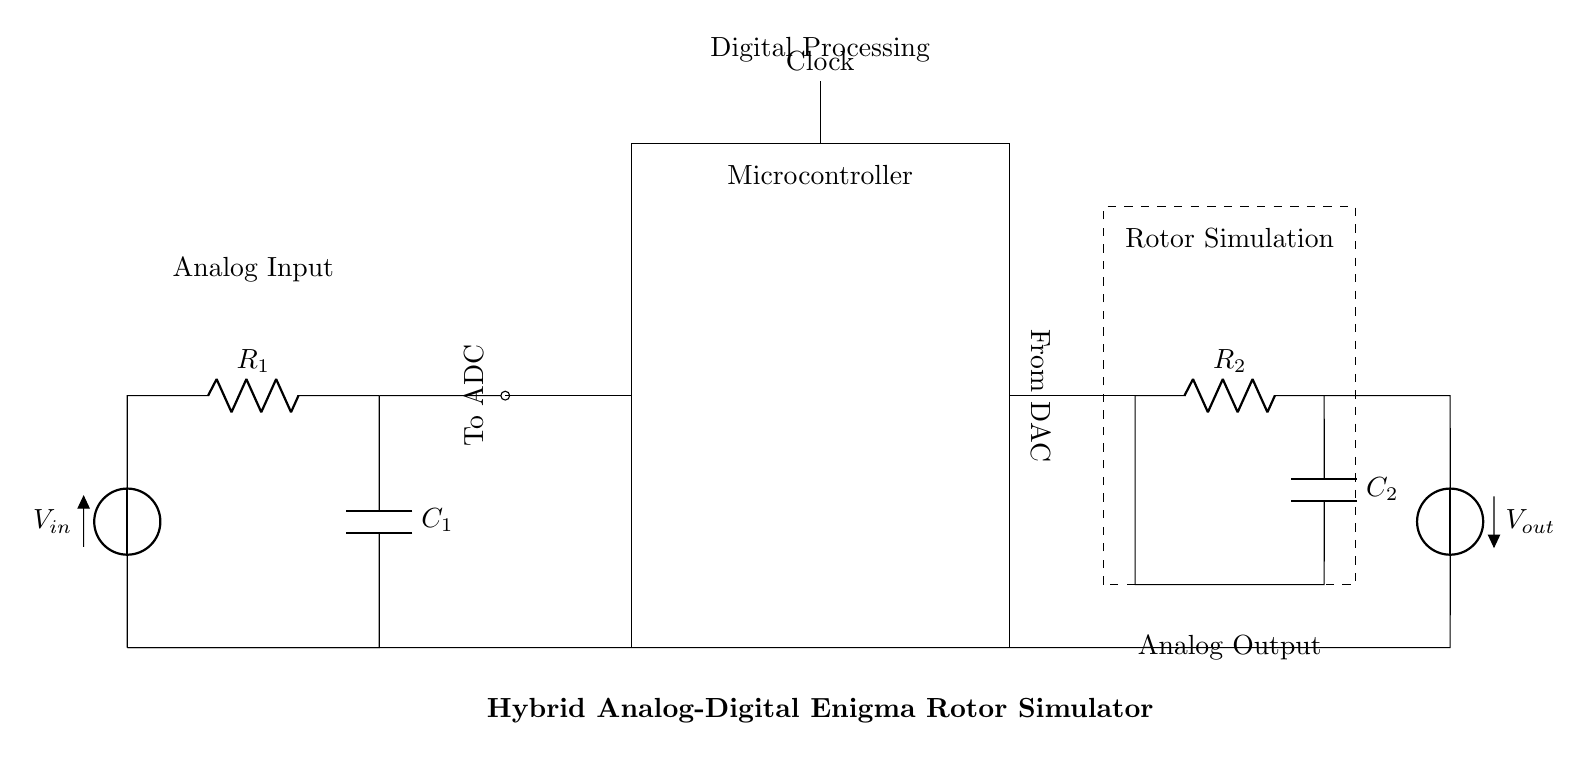What is the input voltage of the circuit? The input voltage is represented by the symbol V_in in the circuit, indicating the source voltage for the analog section.
Answer: V_in What type of component is R_1? R_1 is labeled as a resistor in the analog section of the circuit, indicating that it is a component used to limit current or divide voltage.
Answer: Resistor What does the microcontroller interface with in this circuit? The microcontroller interfaces with the ADC for analog-to-digital conversion and the DAC for digital-to-analog conversion, enabling it to process and generate signals.
Answer: ADC and DAC What is the function of C_1 in this circuit? C_1, as a capacitor, functions to store energy and smooth out fluctuations in the voltage across R_1, assisting in the stabilization of the input signal.
Answer: Energy storage Explain the relationship between the rotor simulation and the resistors and capacitors in its section. The rotor simulation utilizes R_2 and C_2 to simulate the behavior of the rotors in the Enigma machine. The resistor controls the current flow while the capacitor influences the timing and phase of the signal, effectively mimicking the rotor mechanism's dynamic response and changing states.
Answer: Resistor and capacitor simulate rotor behavior What is the output voltage of the circuit? The output voltage, indicated by V_out, is the voltage that results from the processes of the analog and digital sections as well as the rotor simulation, providing the final signal produced by the circuit.
Answer: V_out 